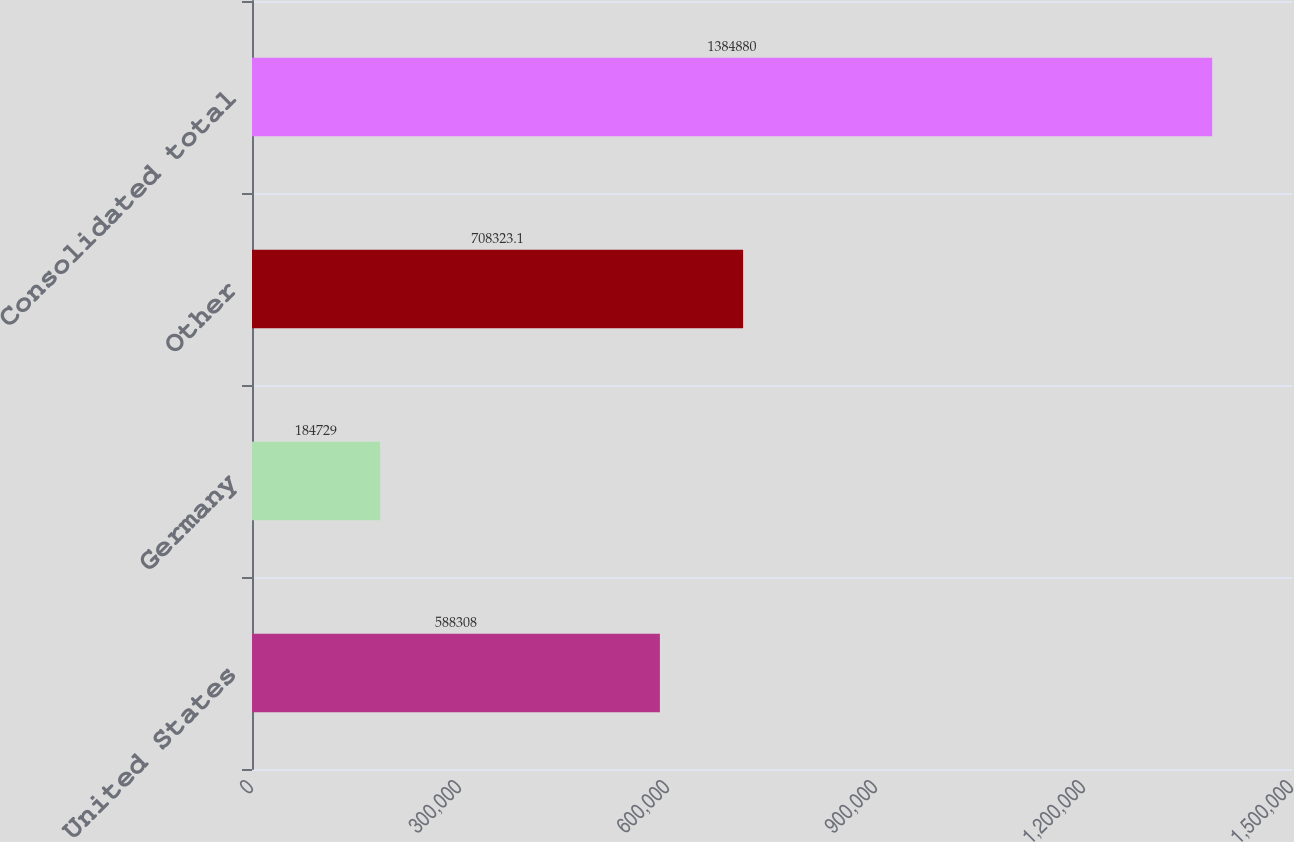Convert chart. <chart><loc_0><loc_0><loc_500><loc_500><bar_chart><fcel>United States<fcel>Germany<fcel>Other<fcel>Consolidated total<nl><fcel>588308<fcel>184729<fcel>708323<fcel>1.38488e+06<nl></chart> 